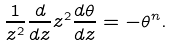Convert formula to latex. <formula><loc_0><loc_0><loc_500><loc_500>\frac { 1 } { z ^ { 2 } } \frac { d } { d z } z ^ { 2 } \frac { d \theta } { d z } = - \theta ^ { n } .</formula> 